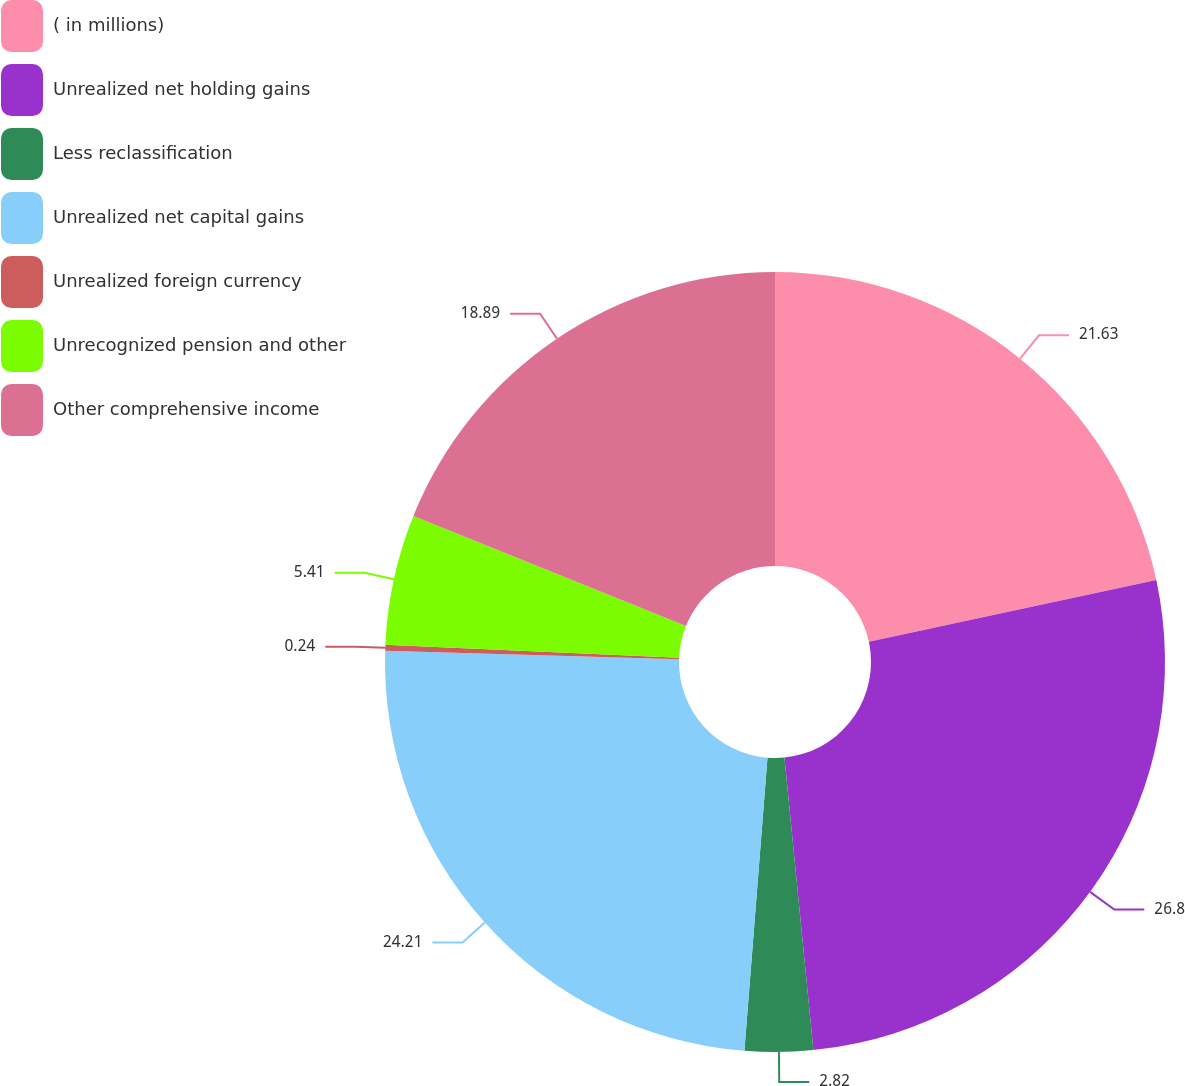Convert chart. <chart><loc_0><loc_0><loc_500><loc_500><pie_chart><fcel>( in millions)<fcel>Unrealized net holding gains<fcel>Less reclassification<fcel>Unrealized net capital gains<fcel>Unrealized foreign currency<fcel>Unrecognized pension and other<fcel>Other comprehensive income<nl><fcel>21.63%<fcel>26.8%<fcel>2.82%<fcel>24.21%<fcel>0.24%<fcel>5.41%<fcel>18.89%<nl></chart> 